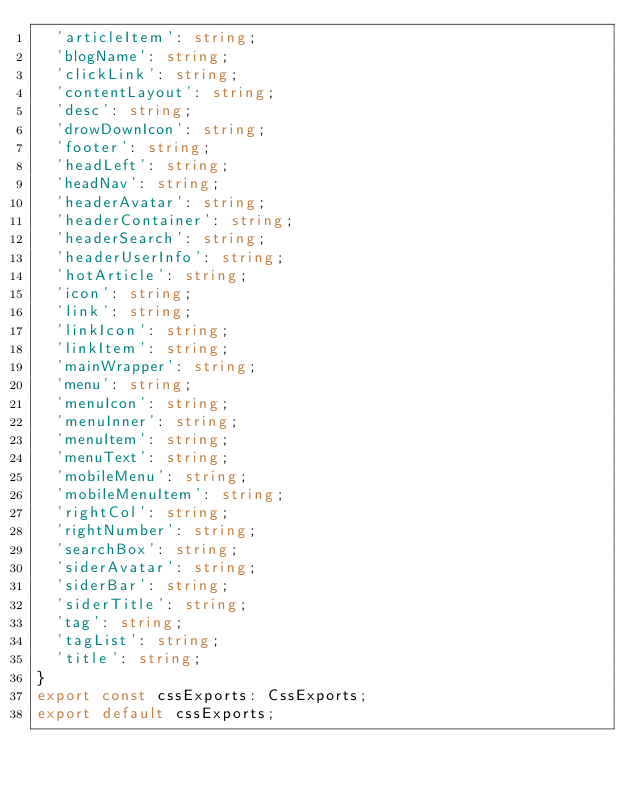<code> <loc_0><loc_0><loc_500><loc_500><_TypeScript_>  'articleItem': string;
  'blogName': string;
  'clickLink': string;
  'contentLayout': string;
  'desc': string;
  'drowDownIcon': string;
  'footer': string;
  'headLeft': string;
  'headNav': string;
  'headerAvatar': string;
  'headerContainer': string;
  'headerSearch': string;
  'headerUserInfo': string;
  'hotArticle': string;
  'icon': string;
  'link': string;
  'linkIcon': string;
  'linkItem': string;
  'mainWrapper': string;
  'menu': string;
  'menuIcon': string;
  'menuInner': string;
  'menuItem': string;
  'menuText': string;
  'mobileMenu': string;
  'mobileMenuItem': string;
  'rightCol': string;
  'rightNumber': string;
  'searchBox': string;
  'siderAvatar': string;
  'siderBar': string;
  'siderTitle': string;
  'tag': string;
  'tagList': string;
  'title': string;
}
export const cssExports: CssExports;
export default cssExports;
</code> 